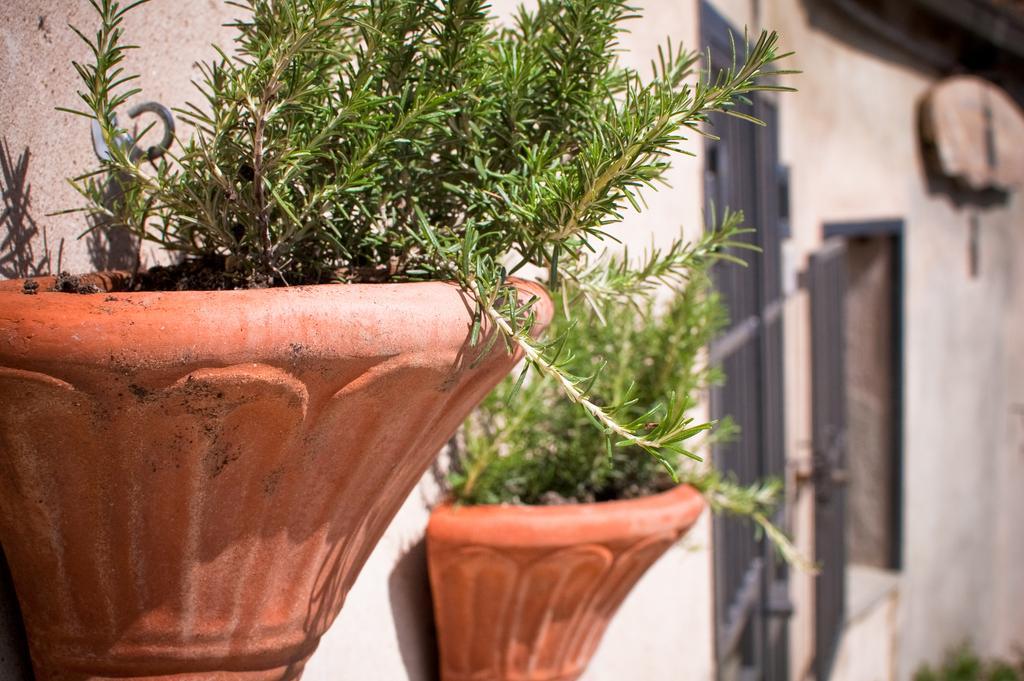How would you summarize this image in a sentence or two? There are plants. In the background we can see wall. 